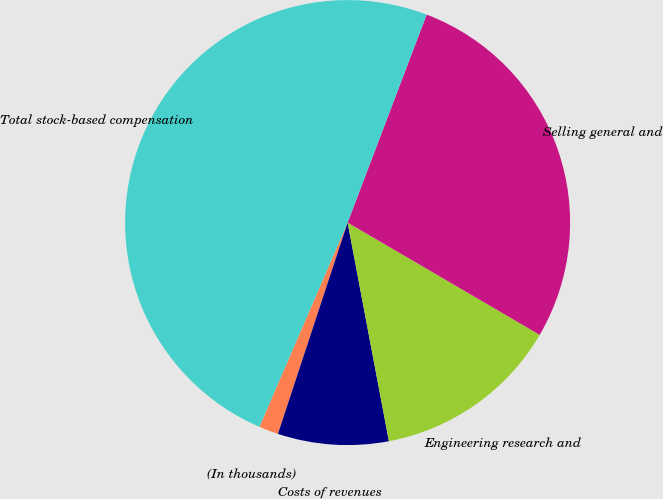<chart> <loc_0><loc_0><loc_500><loc_500><pie_chart><fcel>(In thousands)<fcel>Costs of revenues<fcel>Engineering research and<fcel>Selling general and<fcel>Total stock-based compensation<nl><fcel>1.42%<fcel>8.04%<fcel>13.61%<fcel>27.64%<fcel>49.29%<nl></chart> 